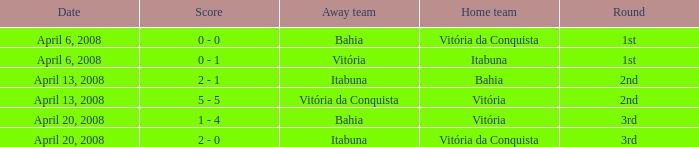Who played as the home team when Vitória was the away team? Itabuna. 